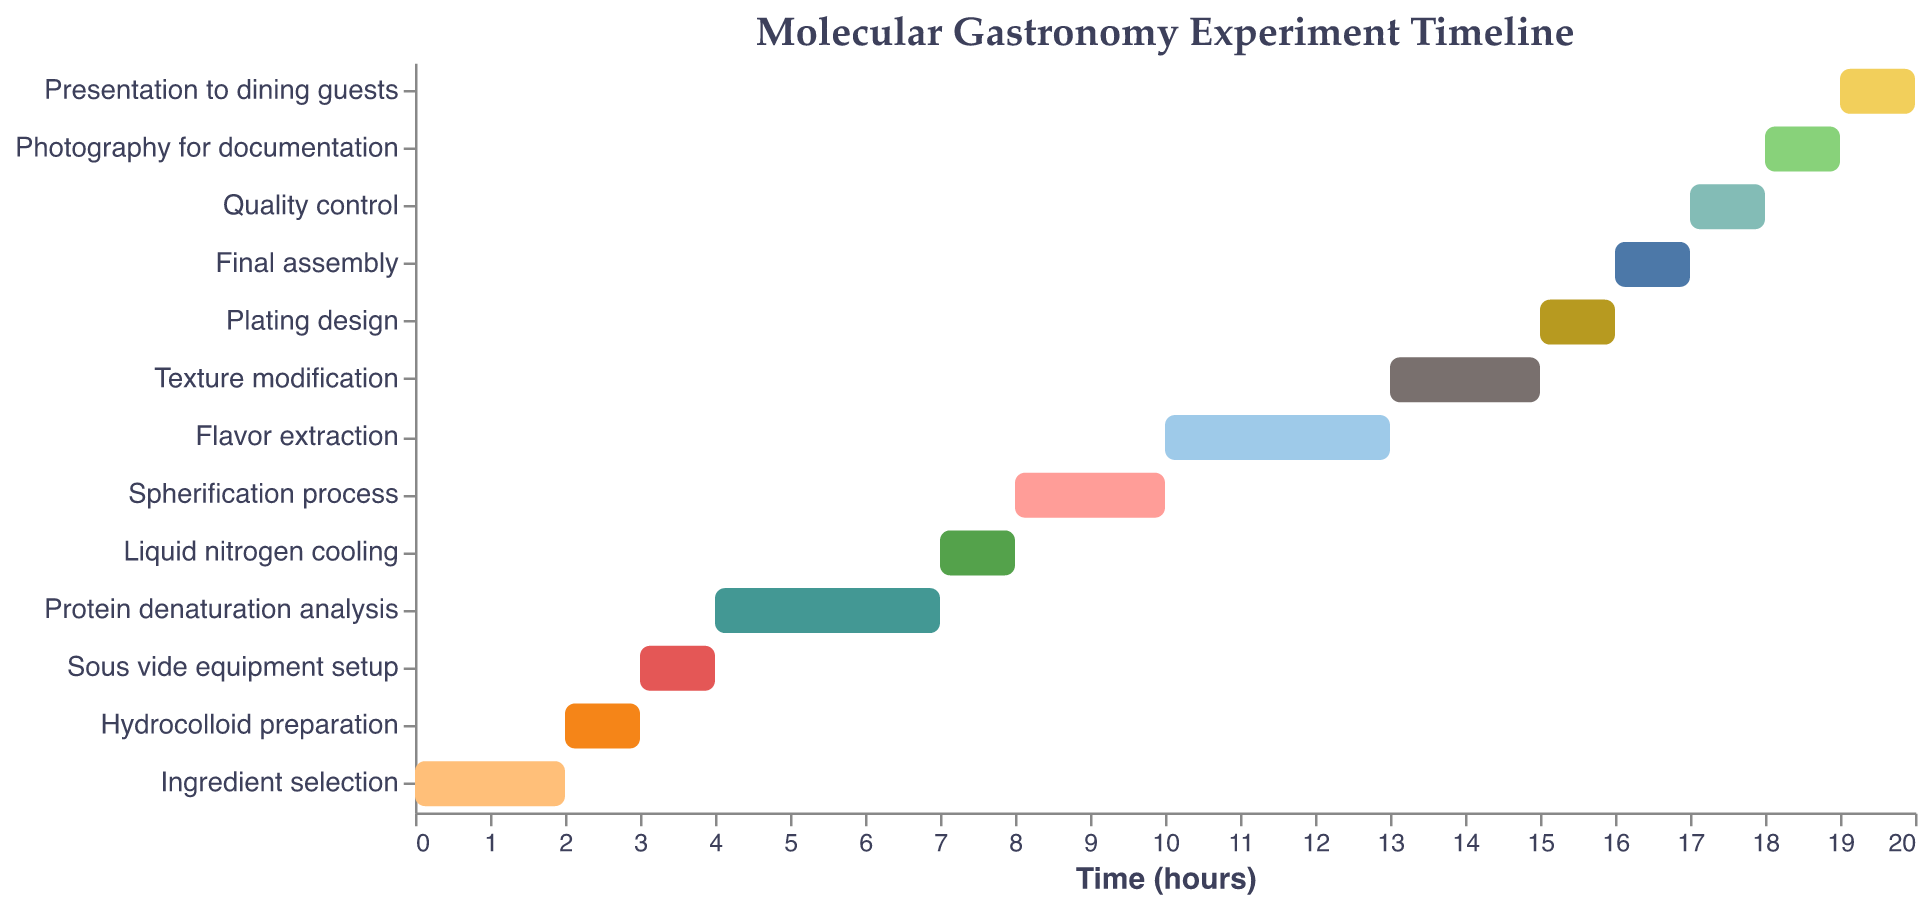What is the duration of the "Protein denaturation analysis" task? The figure indicates that each bar's length represents the duration of the corresponding task. The bar for "Protein denaturation analysis" extends from hour 4 to hour 7, indicating a duration of 3 hours.
Answer: 3 hours At what time does the "Flavor extraction" start? The figure shows the starting times of each task on the x-axis. The "Flavor extraction" task starts at hour 10.
Answer: Hour 10 Which tasks have the same duration of one hour? By inspecting the lengths of the bars, it is clear that "Hydrocolloid preparation", "Sous vide equipment setup", "Liquid nitrogen cooling", "Plating design", "Final assembly", "Quality control", "Photography for documentation", and "Presentation to dining guests" all have bars extending for one hour.
Answer: Eight tasks What is the total duration from "Ingredient selection" to "Final assembly"? The start of "Ingredient selection" is at hour 0 and the end of "Final assembly" is at hour 17. The total duration is the difference between these two times.
Answer: 17 hours Which task starts immediately after the "Liquid nitrogen cooling"? Referring to the start times, "Liquid nitrogen cooling" ends at hour 8. The next task starting immediately after this is "Spherification process", which starts at hour 8.
Answer: Spherification process What is the time duration between the end of "Sous vide equipment setup" and the start of "Spherification process"? "Sous vide equipment setup" ends at hour 4 and "Spherification process" starts at hour 8. The duration between these times is 8 - 4 = 4 hours.
Answer: 4 hours What is the latest task in the timeline? The x-axis represents time, and the last task starting at hour 19 is "Presentation to dining guests".
Answer: Presentation to dining guests How does the duration of "Texturing modification" compare to "Spherification process"? "Texture modification" has a duration of 2 hours, starting at hour 13 and ending at hour 15. "Spherification process" also has a duration of 2 hours, starting at hour 8 and ending at hour 10. Both tasks have the same duration.
Answer: Equal Which task required the longest duration, and how long is it? By comparing the lengths of the bars, "Protein denaturation analysis" and "Flavor extraction" both have the longest durations of 3 hours each.
Answer: Protein denaturation analysis and Flavor extraction, 3 hours How many tasks have durations longer than one hour? By assessing each bar's length in the Gantt chart, it is observed that five tasks ("Ingredient selection", "Protein denaturation analysis", "Spherification process", "Flavor extraction", "Texture modification") have durations longer than one hour.
Answer: Five tasks 